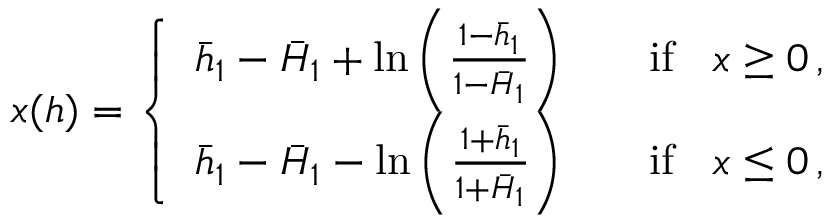Convert formula to latex. <formula><loc_0><loc_0><loc_500><loc_500>x ( h ) = \left \{ \begin{array} { l l } { \bar { h } _ { 1 } - \bar { H } _ { 1 } + \ln \left ( \frac { 1 - \bar { h } _ { 1 } } { 1 - \bar { H } _ { 1 } } \right ) } & { \quad i f \, x \geq 0 \, , } \\ { \bar { h } _ { 1 } - \bar { H } _ { 1 } - \ln \left ( \frac { 1 + \bar { h } _ { 1 } } { 1 + \bar { H } _ { 1 } } \right ) } & { \quad i f \, x \leq 0 \, , } \end{array}</formula> 